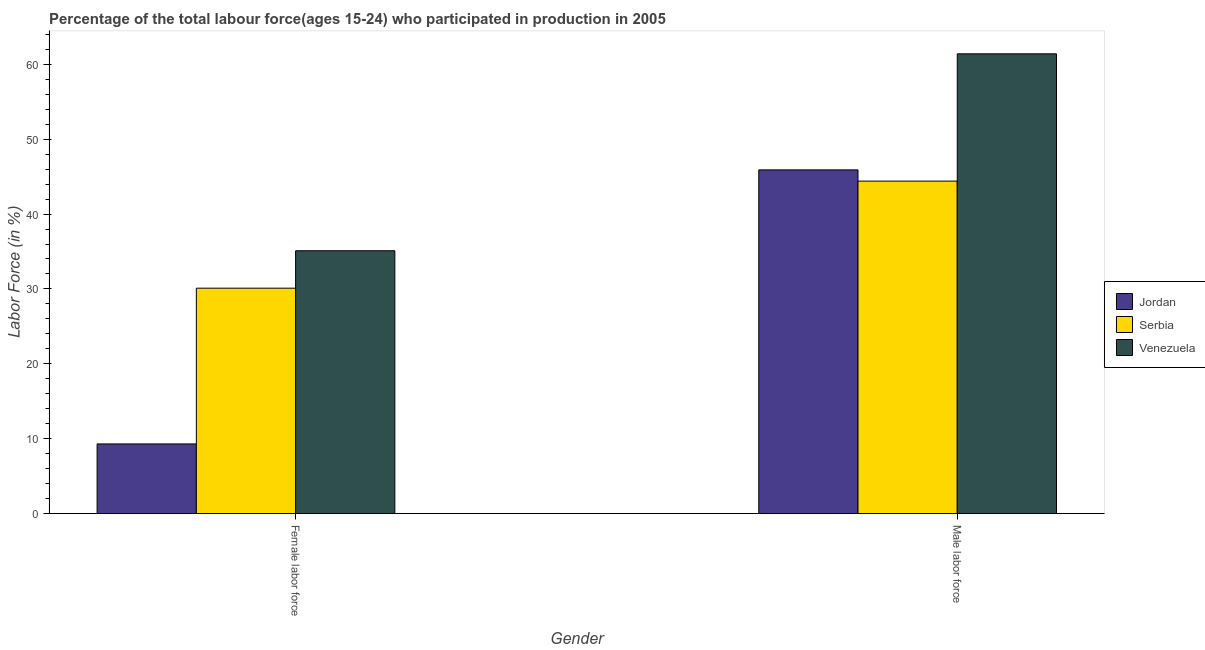How many groups of bars are there?
Your answer should be compact. 2. How many bars are there on the 1st tick from the left?
Provide a succinct answer. 3. What is the label of the 1st group of bars from the left?
Provide a succinct answer. Female labor force. What is the percentage of female labor force in Venezuela?
Keep it short and to the point. 35.1. Across all countries, what is the maximum percentage of female labor force?
Your answer should be compact. 35.1. Across all countries, what is the minimum percentage of female labor force?
Give a very brief answer. 9.3. In which country was the percentage of female labor force maximum?
Your answer should be compact. Venezuela. In which country was the percentage of male labour force minimum?
Your answer should be compact. Serbia. What is the total percentage of female labor force in the graph?
Provide a short and direct response. 74.5. What is the difference between the percentage of female labor force in Venezuela and that in Jordan?
Your answer should be compact. 25.8. What is the difference between the percentage of male labour force in Venezuela and the percentage of female labor force in Serbia?
Make the answer very short. 31.3. What is the average percentage of male labour force per country?
Ensure brevity in your answer.  50.57. What is the difference between the percentage of male labour force and percentage of female labor force in Venezuela?
Offer a very short reply. 26.3. In how many countries, is the percentage of male labour force greater than 24 %?
Your answer should be very brief. 3. What is the ratio of the percentage of male labour force in Jordan to that in Venezuela?
Your response must be concise. 0.75. Is the percentage of male labour force in Serbia less than that in Jordan?
Keep it short and to the point. Yes. In how many countries, is the percentage of male labour force greater than the average percentage of male labour force taken over all countries?
Your response must be concise. 1. What does the 1st bar from the left in Male labor force represents?
Your answer should be very brief. Jordan. What does the 3rd bar from the right in Female labor force represents?
Your answer should be very brief. Jordan. Are all the bars in the graph horizontal?
Make the answer very short. No. How many countries are there in the graph?
Your answer should be very brief. 3. What is the difference between two consecutive major ticks on the Y-axis?
Your response must be concise. 10. Are the values on the major ticks of Y-axis written in scientific E-notation?
Keep it short and to the point. No. Does the graph contain any zero values?
Keep it short and to the point. No. Where does the legend appear in the graph?
Your answer should be very brief. Center right. What is the title of the graph?
Your response must be concise. Percentage of the total labour force(ages 15-24) who participated in production in 2005. Does "Burundi" appear as one of the legend labels in the graph?
Provide a short and direct response. No. What is the label or title of the Y-axis?
Make the answer very short. Labor Force (in %). What is the Labor Force (in %) in Jordan in Female labor force?
Ensure brevity in your answer.  9.3. What is the Labor Force (in %) of Serbia in Female labor force?
Give a very brief answer. 30.1. What is the Labor Force (in %) of Venezuela in Female labor force?
Your answer should be compact. 35.1. What is the Labor Force (in %) in Jordan in Male labor force?
Offer a terse response. 45.9. What is the Labor Force (in %) in Serbia in Male labor force?
Give a very brief answer. 44.4. What is the Labor Force (in %) in Venezuela in Male labor force?
Offer a very short reply. 61.4. Across all Gender, what is the maximum Labor Force (in %) in Jordan?
Offer a very short reply. 45.9. Across all Gender, what is the maximum Labor Force (in %) of Serbia?
Your answer should be very brief. 44.4. Across all Gender, what is the maximum Labor Force (in %) in Venezuela?
Offer a very short reply. 61.4. Across all Gender, what is the minimum Labor Force (in %) in Jordan?
Make the answer very short. 9.3. Across all Gender, what is the minimum Labor Force (in %) of Serbia?
Your answer should be very brief. 30.1. Across all Gender, what is the minimum Labor Force (in %) of Venezuela?
Ensure brevity in your answer.  35.1. What is the total Labor Force (in %) of Jordan in the graph?
Your response must be concise. 55.2. What is the total Labor Force (in %) of Serbia in the graph?
Provide a short and direct response. 74.5. What is the total Labor Force (in %) of Venezuela in the graph?
Your response must be concise. 96.5. What is the difference between the Labor Force (in %) in Jordan in Female labor force and that in Male labor force?
Provide a short and direct response. -36.6. What is the difference between the Labor Force (in %) of Serbia in Female labor force and that in Male labor force?
Offer a terse response. -14.3. What is the difference between the Labor Force (in %) in Venezuela in Female labor force and that in Male labor force?
Provide a succinct answer. -26.3. What is the difference between the Labor Force (in %) in Jordan in Female labor force and the Labor Force (in %) in Serbia in Male labor force?
Make the answer very short. -35.1. What is the difference between the Labor Force (in %) in Jordan in Female labor force and the Labor Force (in %) in Venezuela in Male labor force?
Your answer should be very brief. -52.1. What is the difference between the Labor Force (in %) of Serbia in Female labor force and the Labor Force (in %) of Venezuela in Male labor force?
Ensure brevity in your answer.  -31.3. What is the average Labor Force (in %) in Jordan per Gender?
Offer a terse response. 27.6. What is the average Labor Force (in %) of Serbia per Gender?
Provide a short and direct response. 37.25. What is the average Labor Force (in %) of Venezuela per Gender?
Your answer should be compact. 48.25. What is the difference between the Labor Force (in %) of Jordan and Labor Force (in %) of Serbia in Female labor force?
Offer a very short reply. -20.8. What is the difference between the Labor Force (in %) of Jordan and Labor Force (in %) of Venezuela in Female labor force?
Give a very brief answer. -25.8. What is the difference between the Labor Force (in %) in Jordan and Labor Force (in %) in Serbia in Male labor force?
Ensure brevity in your answer.  1.5. What is the difference between the Labor Force (in %) in Jordan and Labor Force (in %) in Venezuela in Male labor force?
Offer a very short reply. -15.5. What is the difference between the Labor Force (in %) in Serbia and Labor Force (in %) in Venezuela in Male labor force?
Your answer should be compact. -17. What is the ratio of the Labor Force (in %) in Jordan in Female labor force to that in Male labor force?
Your answer should be compact. 0.2. What is the ratio of the Labor Force (in %) of Serbia in Female labor force to that in Male labor force?
Your response must be concise. 0.68. What is the ratio of the Labor Force (in %) in Venezuela in Female labor force to that in Male labor force?
Offer a very short reply. 0.57. What is the difference between the highest and the second highest Labor Force (in %) of Jordan?
Make the answer very short. 36.6. What is the difference between the highest and the second highest Labor Force (in %) of Venezuela?
Offer a very short reply. 26.3. What is the difference between the highest and the lowest Labor Force (in %) of Jordan?
Provide a short and direct response. 36.6. What is the difference between the highest and the lowest Labor Force (in %) of Venezuela?
Your answer should be compact. 26.3. 